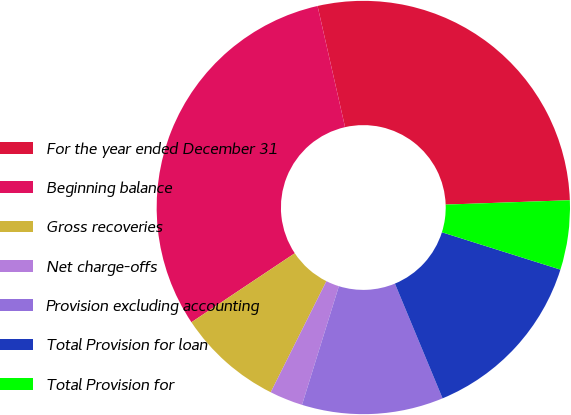<chart> <loc_0><loc_0><loc_500><loc_500><pie_chart><fcel>For the year ended December 31<fcel>Beginning balance<fcel>Gross recoveries<fcel>Net charge-offs<fcel>Provision excluding accounting<fcel>Total Provision for loan<fcel>Total Provision for<nl><fcel>28.0%<fcel>30.82%<fcel>8.24%<fcel>2.6%<fcel>11.06%<fcel>13.88%<fcel>5.42%<nl></chart> 